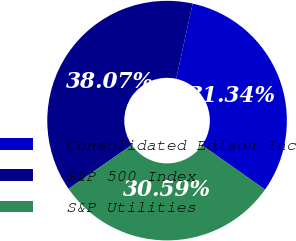<chart> <loc_0><loc_0><loc_500><loc_500><pie_chart><fcel>Consolidated Edison Inc<fcel>S&P 500 Index<fcel>S&P Utilities<nl><fcel>31.34%<fcel>38.07%<fcel>30.59%<nl></chart> 